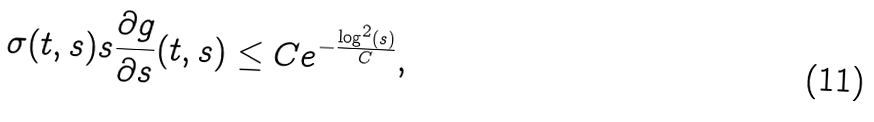<formula> <loc_0><loc_0><loc_500><loc_500>\sigma ( t , s ) s \frac { \partial g } { \partial s } ( t , s ) & \leq C e ^ { - \frac { \log ^ { 2 } ( s ) } { C } } ,</formula> 